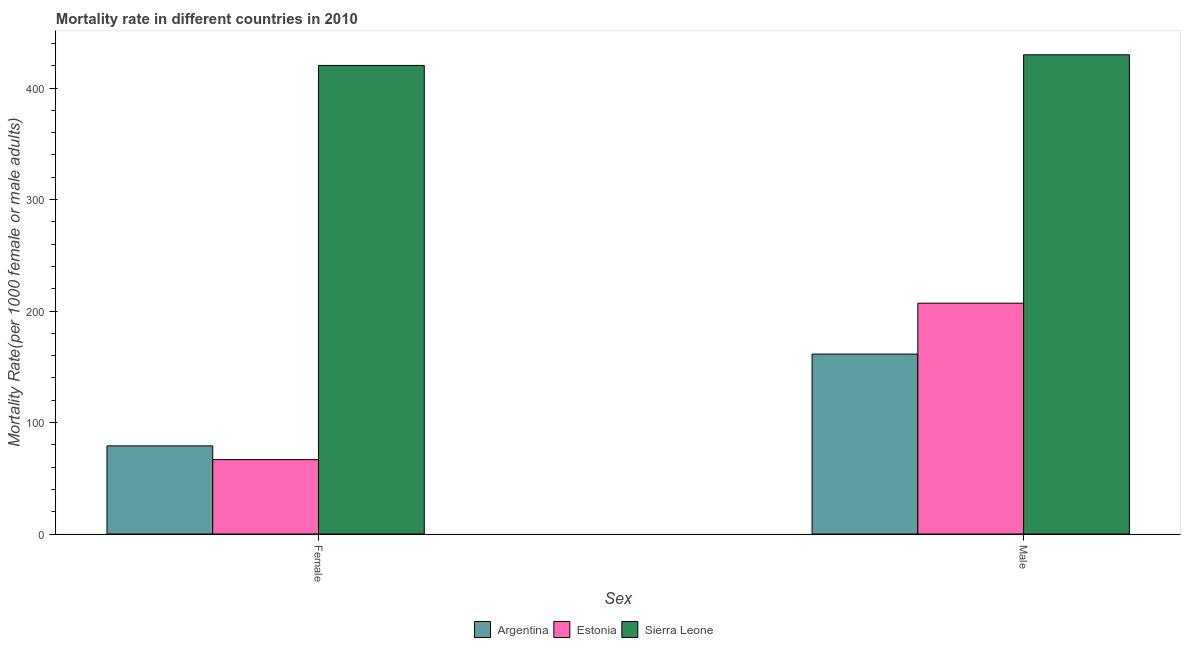How many groups of bars are there?
Your answer should be compact. 2. Are the number of bars on each tick of the X-axis equal?
Make the answer very short. Yes. How many bars are there on the 1st tick from the left?
Your response must be concise. 3. What is the male mortality rate in Argentina?
Keep it short and to the point. 161.41. Across all countries, what is the maximum female mortality rate?
Your response must be concise. 420.33. Across all countries, what is the minimum male mortality rate?
Provide a succinct answer. 161.41. In which country was the female mortality rate maximum?
Keep it short and to the point. Sierra Leone. In which country was the female mortality rate minimum?
Your response must be concise. Estonia. What is the total female mortality rate in the graph?
Offer a very short reply. 566.08. What is the difference between the male mortality rate in Sierra Leone and that in Argentina?
Your response must be concise. 268.47. What is the difference between the male mortality rate in Argentina and the female mortality rate in Sierra Leone?
Give a very brief answer. -258.92. What is the average male mortality rate per country?
Your response must be concise. 266.11. What is the difference between the male mortality rate and female mortality rate in Argentina?
Your answer should be very brief. 82.37. In how many countries, is the female mortality rate greater than 200 ?
Make the answer very short. 1. What is the ratio of the female mortality rate in Estonia to that in Argentina?
Offer a terse response. 0.84. In how many countries, is the female mortality rate greater than the average female mortality rate taken over all countries?
Ensure brevity in your answer.  1. What does the 2nd bar from the right in Female represents?
Your answer should be compact. Estonia. Are all the bars in the graph horizontal?
Make the answer very short. No. What is the difference between two consecutive major ticks on the Y-axis?
Provide a short and direct response. 100. Where does the legend appear in the graph?
Offer a terse response. Bottom center. How many legend labels are there?
Your response must be concise. 3. How are the legend labels stacked?
Offer a very short reply. Horizontal. What is the title of the graph?
Your answer should be very brief. Mortality rate in different countries in 2010. What is the label or title of the X-axis?
Ensure brevity in your answer.  Sex. What is the label or title of the Y-axis?
Your answer should be compact. Mortality Rate(per 1000 female or male adults). What is the Mortality Rate(per 1000 female or male adults) of Argentina in Female?
Offer a terse response. 79.04. What is the Mortality Rate(per 1000 female or male adults) of Estonia in Female?
Make the answer very short. 66.71. What is the Mortality Rate(per 1000 female or male adults) of Sierra Leone in Female?
Give a very brief answer. 420.33. What is the Mortality Rate(per 1000 female or male adults) in Argentina in Male?
Make the answer very short. 161.41. What is the Mortality Rate(per 1000 female or male adults) in Estonia in Male?
Your answer should be compact. 207.04. What is the Mortality Rate(per 1000 female or male adults) of Sierra Leone in Male?
Provide a succinct answer. 429.88. Across all Sex, what is the maximum Mortality Rate(per 1000 female or male adults) in Argentina?
Your answer should be compact. 161.41. Across all Sex, what is the maximum Mortality Rate(per 1000 female or male adults) of Estonia?
Your answer should be compact. 207.04. Across all Sex, what is the maximum Mortality Rate(per 1000 female or male adults) in Sierra Leone?
Provide a short and direct response. 429.88. Across all Sex, what is the minimum Mortality Rate(per 1000 female or male adults) of Argentina?
Make the answer very short. 79.04. Across all Sex, what is the minimum Mortality Rate(per 1000 female or male adults) in Estonia?
Make the answer very short. 66.71. Across all Sex, what is the minimum Mortality Rate(per 1000 female or male adults) of Sierra Leone?
Your answer should be very brief. 420.33. What is the total Mortality Rate(per 1000 female or male adults) of Argentina in the graph?
Give a very brief answer. 240.45. What is the total Mortality Rate(per 1000 female or male adults) in Estonia in the graph?
Make the answer very short. 273.75. What is the total Mortality Rate(per 1000 female or male adults) in Sierra Leone in the graph?
Your answer should be very brief. 850.21. What is the difference between the Mortality Rate(per 1000 female or male adults) of Argentina in Female and that in Male?
Keep it short and to the point. -82.37. What is the difference between the Mortality Rate(per 1000 female or male adults) of Estonia in Female and that in Male?
Provide a succinct answer. -140.34. What is the difference between the Mortality Rate(per 1000 female or male adults) of Sierra Leone in Female and that in Male?
Make the answer very short. -9.54. What is the difference between the Mortality Rate(per 1000 female or male adults) in Argentina in Female and the Mortality Rate(per 1000 female or male adults) in Estonia in Male?
Provide a short and direct response. -128. What is the difference between the Mortality Rate(per 1000 female or male adults) of Argentina in Female and the Mortality Rate(per 1000 female or male adults) of Sierra Leone in Male?
Your response must be concise. -350.83. What is the difference between the Mortality Rate(per 1000 female or male adults) in Estonia in Female and the Mortality Rate(per 1000 female or male adults) in Sierra Leone in Male?
Your answer should be compact. -363.17. What is the average Mortality Rate(per 1000 female or male adults) in Argentina per Sex?
Offer a terse response. 120.22. What is the average Mortality Rate(per 1000 female or male adults) of Estonia per Sex?
Your answer should be very brief. 136.88. What is the average Mortality Rate(per 1000 female or male adults) of Sierra Leone per Sex?
Ensure brevity in your answer.  425.1. What is the difference between the Mortality Rate(per 1000 female or male adults) in Argentina and Mortality Rate(per 1000 female or male adults) in Estonia in Female?
Your answer should be compact. 12.33. What is the difference between the Mortality Rate(per 1000 female or male adults) in Argentina and Mortality Rate(per 1000 female or male adults) in Sierra Leone in Female?
Offer a terse response. -341.29. What is the difference between the Mortality Rate(per 1000 female or male adults) in Estonia and Mortality Rate(per 1000 female or male adults) in Sierra Leone in Female?
Give a very brief answer. -353.62. What is the difference between the Mortality Rate(per 1000 female or male adults) in Argentina and Mortality Rate(per 1000 female or male adults) in Estonia in Male?
Provide a short and direct response. -45.63. What is the difference between the Mortality Rate(per 1000 female or male adults) in Argentina and Mortality Rate(per 1000 female or male adults) in Sierra Leone in Male?
Ensure brevity in your answer.  -268.46. What is the difference between the Mortality Rate(per 1000 female or male adults) in Estonia and Mortality Rate(per 1000 female or male adults) in Sierra Leone in Male?
Give a very brief answer. -222.83. What is the ratio of the Mortality Rate(per 1000 female or male adults) in Argentina in Female to that in Male?
Ensure brevity in your answer.  0.49. What is the ratio of the Mortality Rate(per 1000 female or male adults) in Estonia in Female to that in Male?
Provide a short and direct response. 0.32. What is the ratio of the Mortality Rate(per 1000 female or male adults) of Sierra Leone in Female to that in Male?
Provide a succinct answer. 0.98. What is the difference between the highest and the second highest Mortality Rate(per 1000 female or male adults) of Argentina?
Keep it short and to the point. 82.37. What is the difference between the highest and the second highest Mortality Rate(per 1000 female or male adults) of Estonia?
Keep it short and to the point. 140.34. What is the difference between the highest and the second highest Mortality Rate(per 1000 female or male adults) in Sierra Leone?
Keep it short and to the point. 9.54. What is the difference between the highest and the lowest Mortality Rate(per 1000 female or male adults) in Argentina?
Give a very brief answer. 82.37. What is the difference between the highest and the lowest Mortality Rate(per 1000 female or male adults) of Estonia?
Your answer should be compact. 140.34. What is the difference between the highest and the lowest Mortality Rate(per 1000 female or male adults) in Sierra Leone?
Your answer should be very brief. 9.54. 